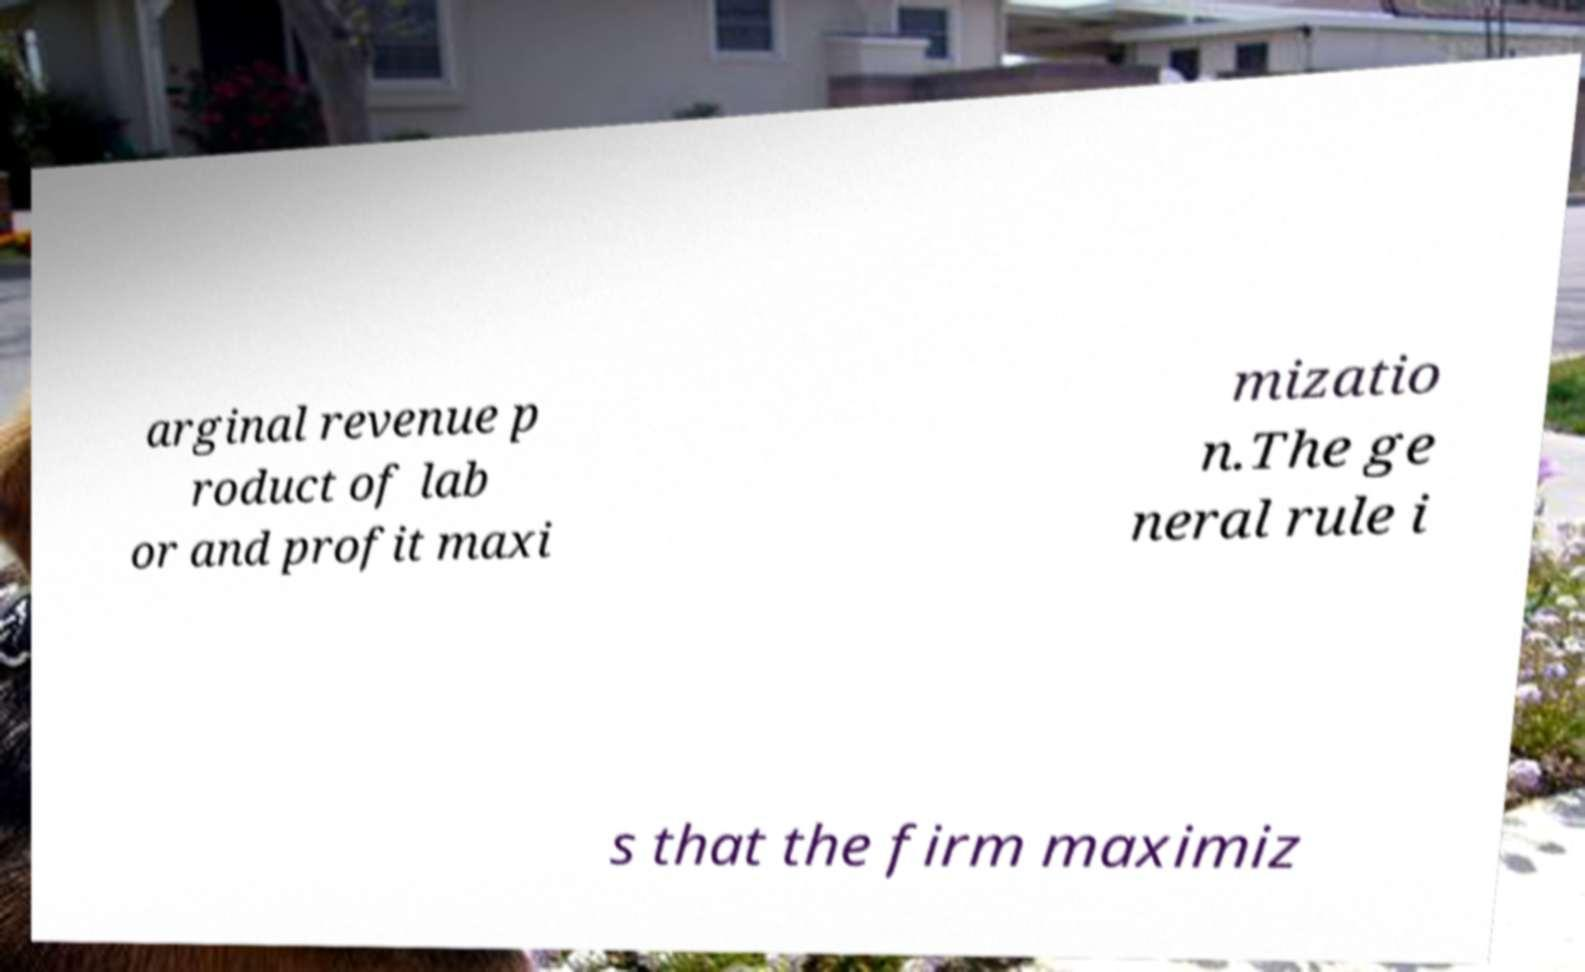For documentation purposes, I need the text within this image transcribed. Could you provide that? arginal revenue p roduct of lab or and profit maxi mizatio n.The ge neral rule i s that the firm maximiz 